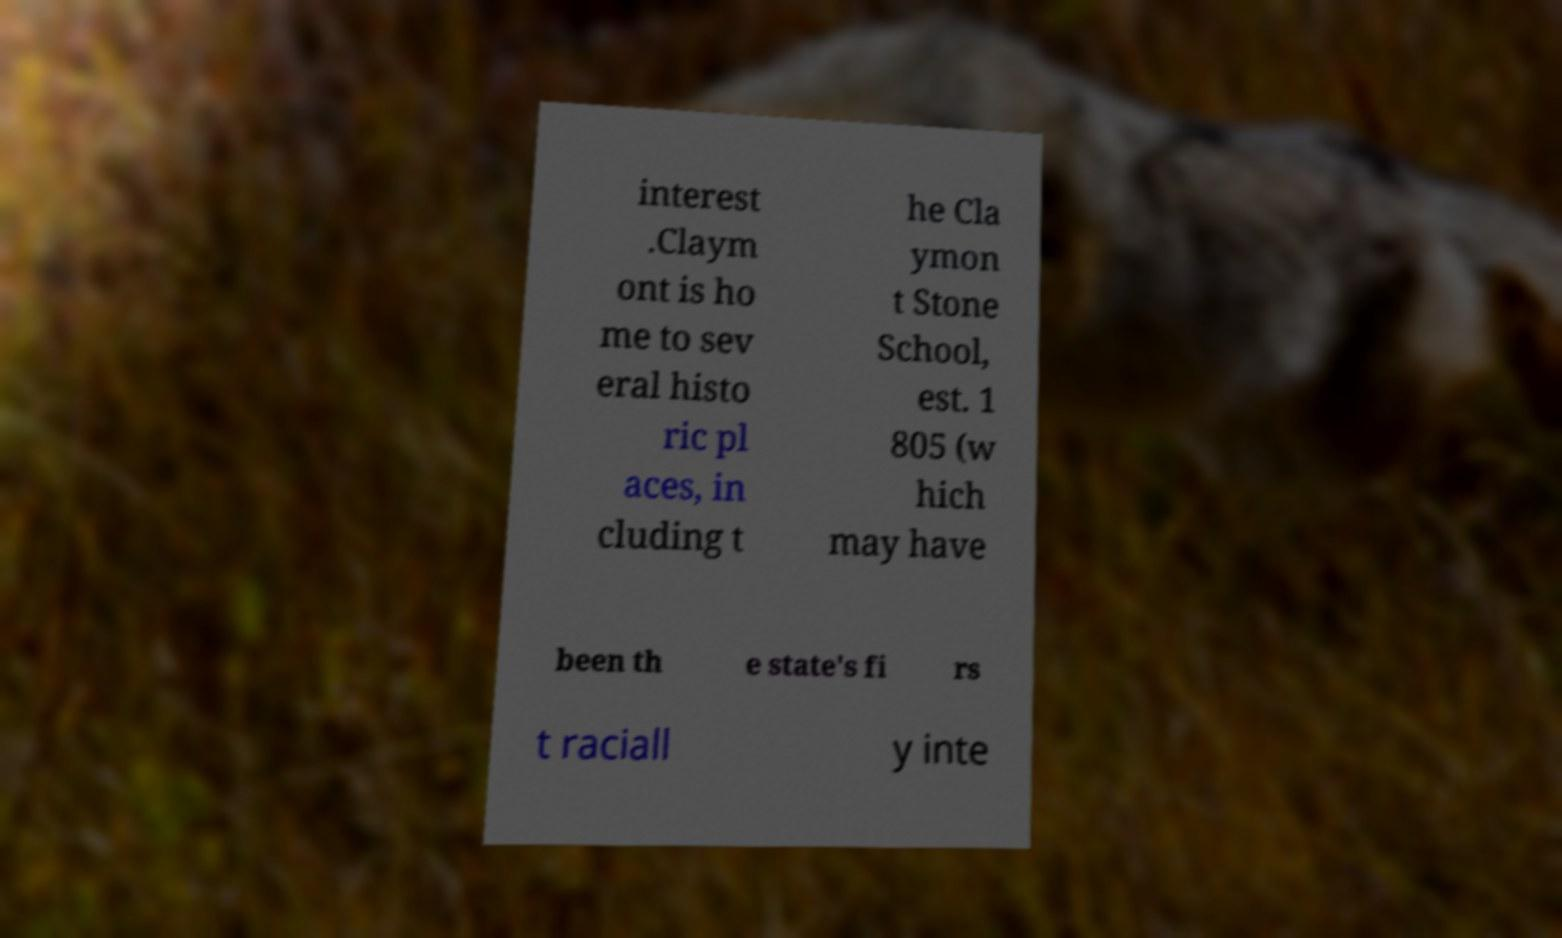Can you read and provide the text displayed in the image?This photo seems to have some interesting text. Can you extract and type it out for me? interest .Claym ont is ho me to sev eral histo ric pl aces, in cluding t he Cla ymon t Stone School, est. 1 805 (w hich may have been th e state's fi rs t raciall y inte 